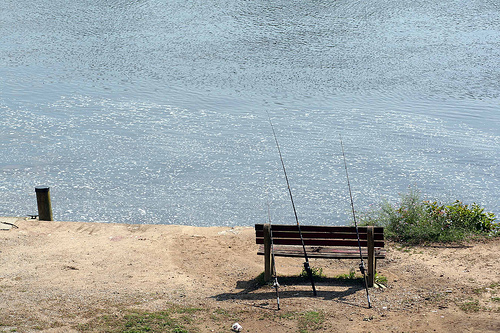<image>
Can you confirm if the water is above the sand? No. The water is not positioned above the sand. The vertical arrangement shows a different relationship. 